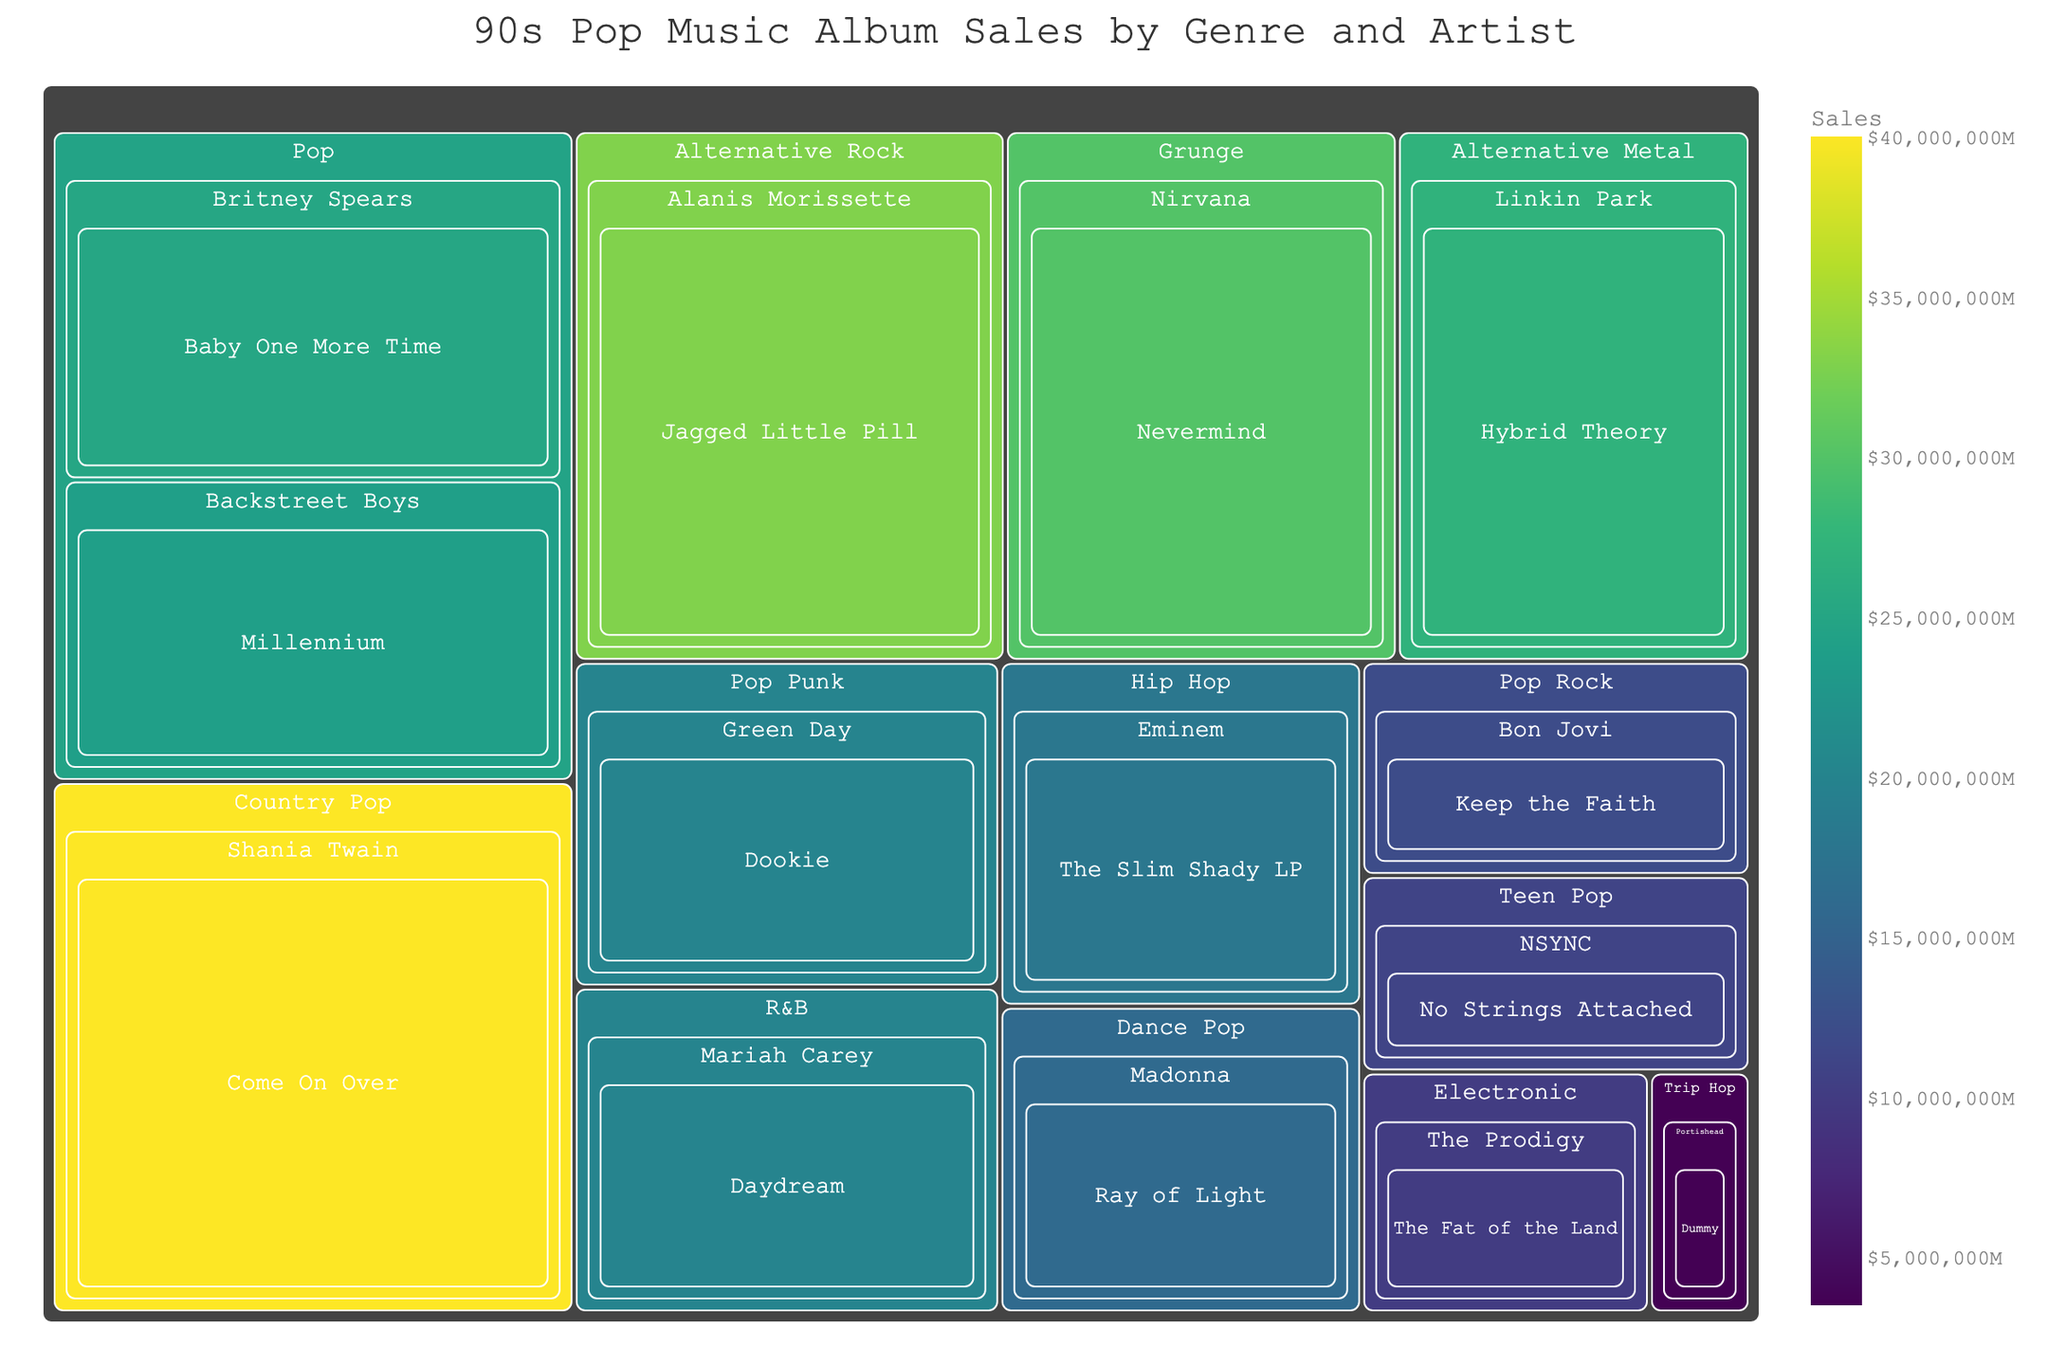Which genre has the highest album sales? Observe the treemap and locate the genre with the largest area. "Country Pop" has the largest area, indicating the highest sales.
Answer: Country Pop What is the total sales figure for Pop albums? Sum the sales of the Pop albums: "Baby One More Time" ($25M) and "Millennium" ($24M). So, $25M + $24M = $49M.
Answer: $49M Who sold more albums, NSYNC or Madonna? Compare the sales figures for NSYNC's "No Strings Attached" ($11M) with Madonna's "Ray of Light" ($16M). $16M is greater than $11M.
Answer: Madonna What is the combined sales figure for Alternative Rock and Grunge genres? Add the sales figures for "Jagged Little Pill" ($33M) and "Nevermind" ($30M). So, $33M + $30M = $63M.
Answer: $63M Among the listed artists, who has the album with the highest sales? Identify the album with the largest sales figure. "Come On Over" by Shania Twain has the highest sales at $40M.
Answer: Shania Twain Which genre has both the most and the least sales figures? The largest sales figure is for "Country Pop" ($40M), and the smallest is "Trip Hop" ($3.5M).
Answer: Country Pop and Trip Hop Which artist in the Hip Hop genre has the highest sales? The only artist listed in the Hip Hop genre is Eminem with "The Slim Shady LP" at $18M.
Answer: Eminem How much more did Alanis Morissette sell than Eminem? Find the difference in sales between "Jagged Little Pill" ($33M) and "The Slim Shady LP" ($18M). So, $33M - $18M = $15M.
Answer: $15M What is the median sale value of the albums listed? List all sales figures ($25M, $24M, $20M, $33M, $30M, $18M, $12M, $10M, $40M, $11M, $16M, $27M, $20M, $3.5M), sort them ([3.5M, 10M, 11M, 12M, 16M, 18M, 20M, 20M, 24M, 25M, 27M, 30M, 33M, 40M]), and find the middle value or the average of two central values. The median is ($20M + $20M)/2 = $20M.
Answer: $20M 